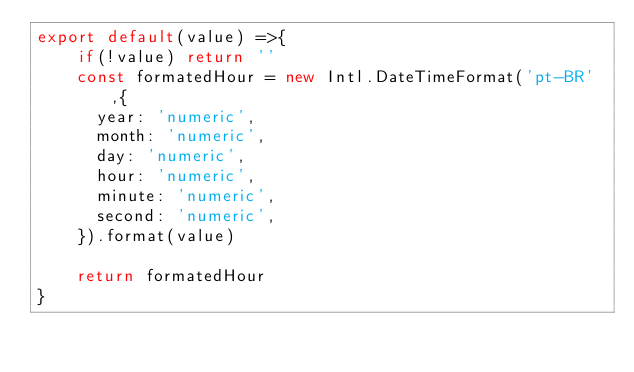<code> <loc_0><loc_0><loc_500><loc_500><_JavaScript_>export default(value) =>{
    if(!value) return ''
    const formatedHour = new Intl.DateTimeFormat('pt-BR',{
      year: 'numeric',
      month: 'numeric',
      day: 'numeric',
      hour: 'numeric',
      minute: 'numeric',
      second: 'numeric',
    }).format(value)

    return formatedHour
}</code> 